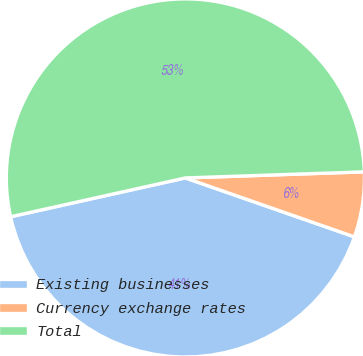<chart> <loc_0><loc_0><loc_500><loc_500><pie_chart><fcel>Existing businesses<fcel>Currency exchange rates<fcel>Total<nl><fcel>41.18%<fcel>5.88%<fcel>52.94%<nl></chart> 